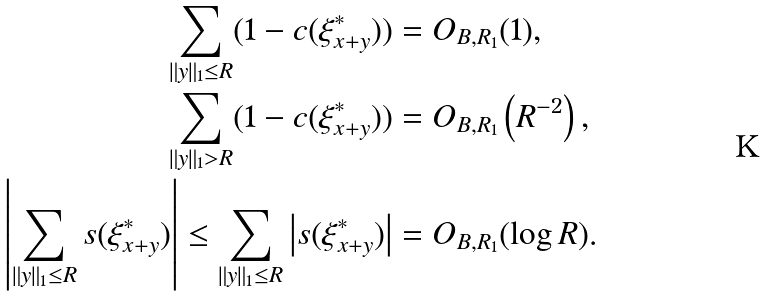Convert formula to latex. <formula><loc_0><loc_0><loc_500><loc_500>\sum _ { \| y \| _ { 1 } \leq R } ( 1 - c ( \xi ^ { * } _ { x + y } ) ) & = O _ { B , R _ { 1 } } ( 1 ) , \\ \sum _ { \| y \| _ { 1 } > R } ( 1 - c ( \xi ^ { * } _ { x + y } ) ) & = O _ { B , R _ { 1 } } \left ( R ^ { - 2 } \right ) , \\ \left | \sum _ { \| y \| _ { 1 } \leq R } s ( \xi ^ { * } _ { x + y } ) \right | \leq \sum _ { \| y \| _ { 1 } \leq R } \left | s ( \xi ^ { * } _ { x + y } ) \right | & = O _ { B , R _ { 1 } } ( \log R ) .</formula> 